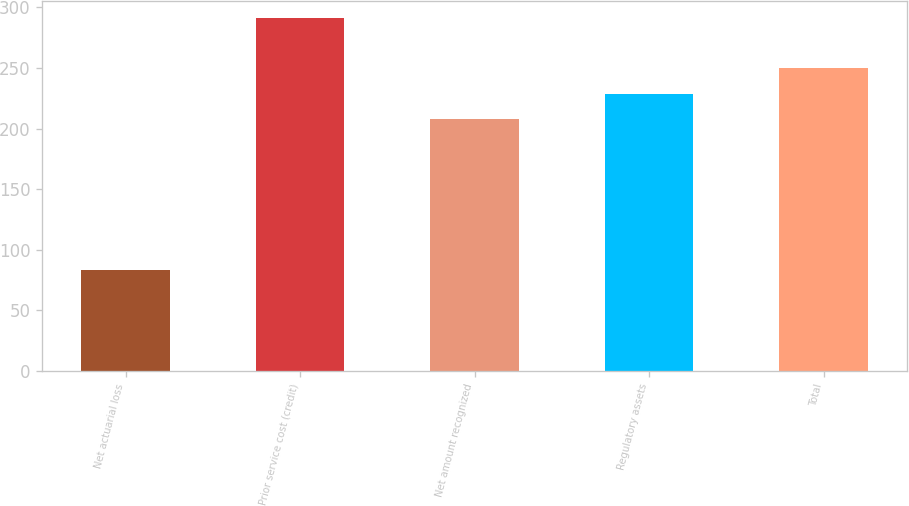<chart> <loc_0><loc_0><loc_500><loc_500><bar_chart><fcel>Net actuarial loss<fcel>Prior service cost (credit)<fcel>Net amount recognized<fcel>Regulatory assets<fcel>Total<nl><fcel>83<fcel>291<fcel>208<fcel>228.8<fcel>249.6<nl></chart> 